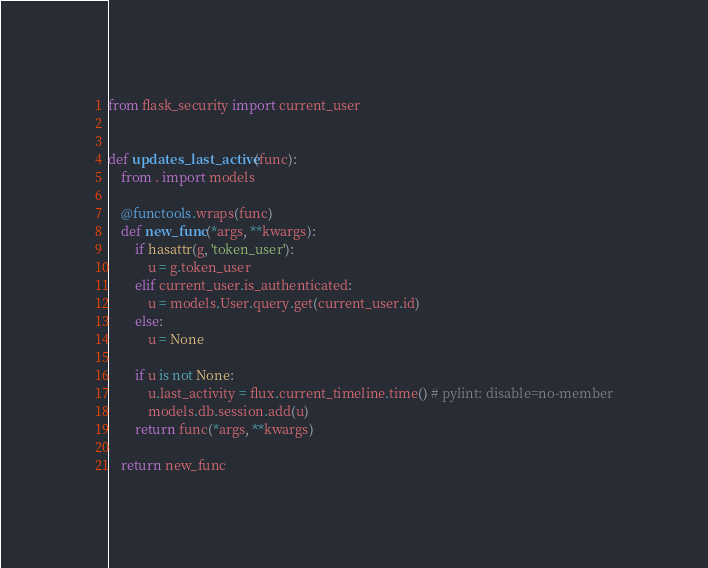<code> <loc_0><loc_0><loc_500><loc_500><_Python_>from flask_security import current_user


def updates_last_active(func):
    from . import models

    @functools.wraps(func)
    def new_func(*args, **kwargs):
        if hasattr(g, 'token_user'):
            u = g.token_user
        elif current_user.is_authenticated:
            u = models.User.query.get(current_user.id)
        else:
            u = None

        if u is not None:
            u.last_activity = flux.current_timeline.time() # pylint: disable=no-member
            models.db.session.add(u)
        return func(*args, **kwargs)

    return new_func
</code> 